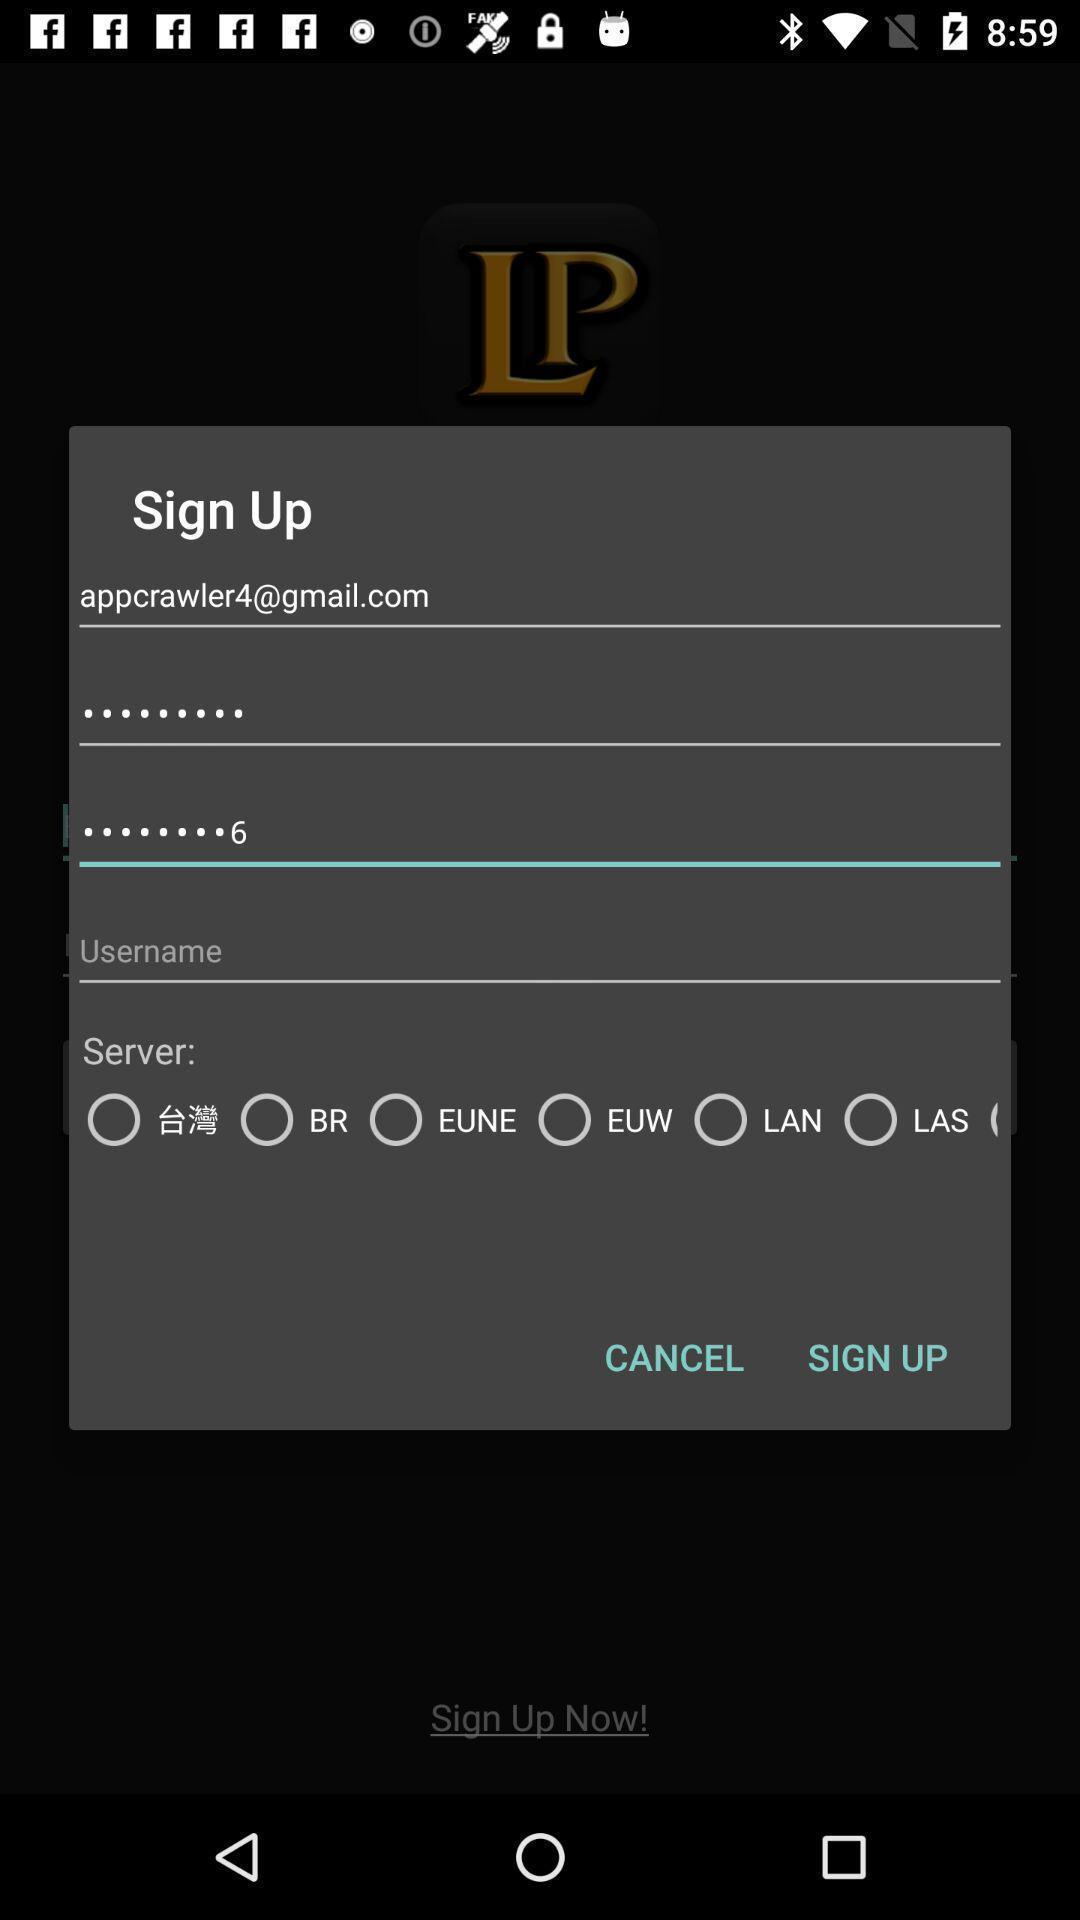Please provide a description for this image. Sign up page. 